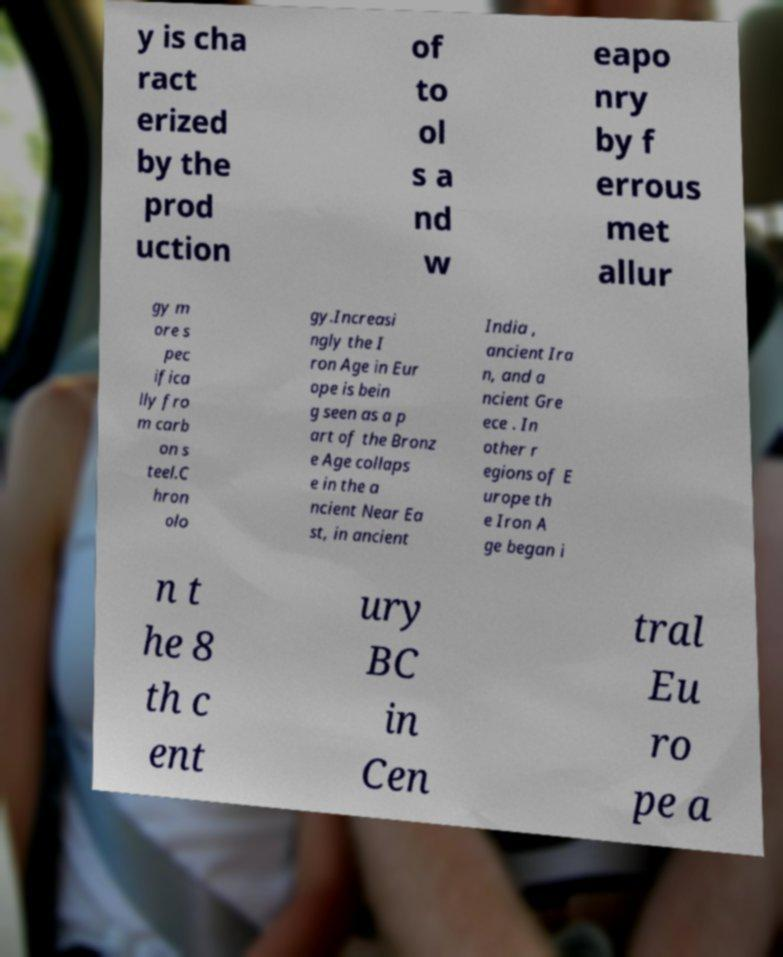Could you extract and type out the text from this image? y is cha ract erized by the prod uction of to ol s a nd w eapo nry by f errous met allur gy m ore s pec ifica lly fro m carb on s teel.C hron olo gy.Increasi ngly the I ron Age in Eur ope is bein g seen as a p art of the Bronz e Age collaps e in the a ncient Near Ea st, in ancient India , ancient Ira n, and a ncient Gre ece . In other r egions of E urope th e Iron A ge began i n t he 8 th c ent ury BC in Cen tral Eu ro pe a 